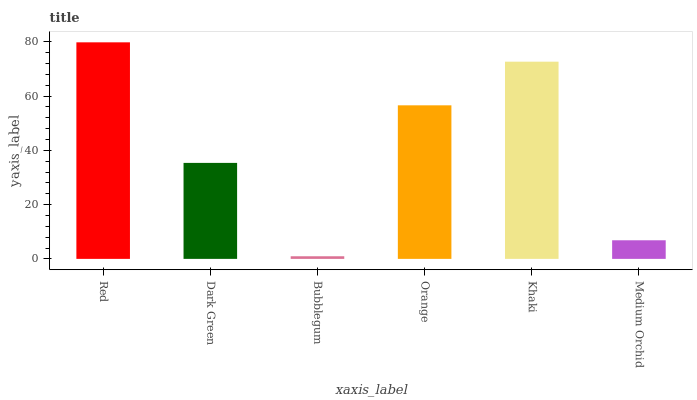Is Dark Green the minimum?
Answer yes or no. No. Is Dark Green the maximum?
Answer yes or no. No. Is Red greater than Dark Green?
Answer yes or no. Yes. Is Dark Green less than Red?
Answer yes or no. Yes. Is Dark Green greater than Red?
Answer yes or no. No. Is Red less than Dark Green?
Answer yes or no. No. Is Orange the high median?
Answer yes or no. Yes. Is Dark Green the low median?
Answer yes or no. Yes. Is Bubblegum the high median?
Answer yes or no. No. Is Khaki the low median?
Answer yes or no. No. 